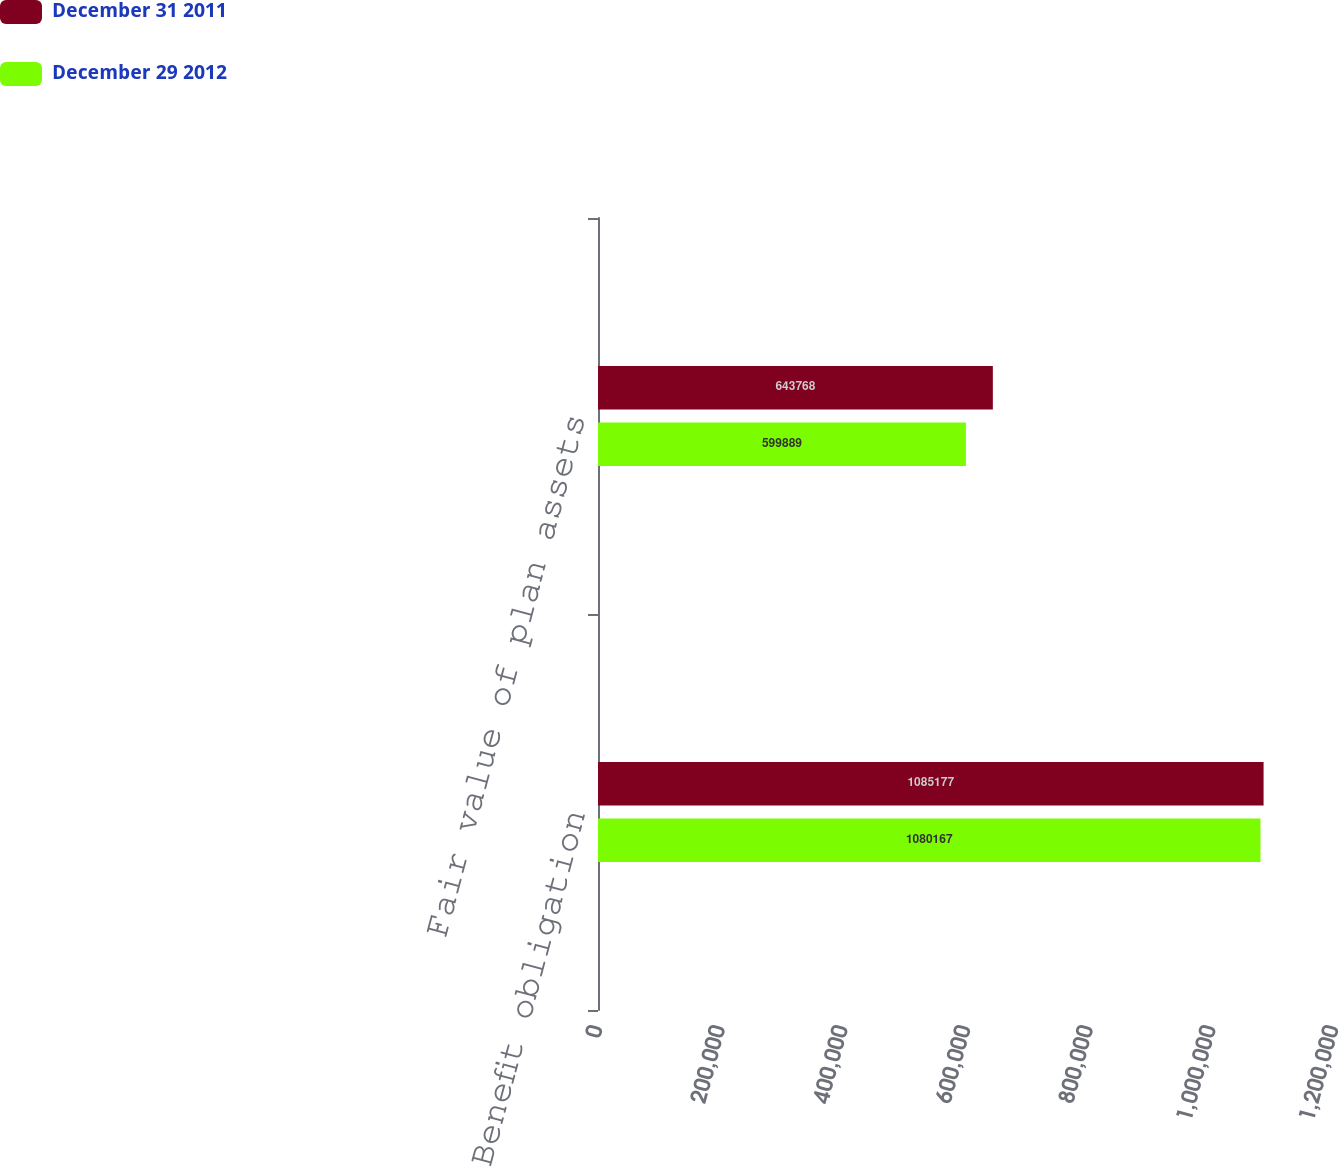Convert chart to OTSL. <chart><loc_0><loc_0><loc_500><loc_500><stacked_bar_chart><ecel><fcel>Benefit obligation<fcel>Fair value of plan assets<nl><fcel>December 31 2011<fcel>1.08518e+06<fcel>643768<nl><fcel>December 29 2012<fcel>1.08017e+06<fcel>599889<nl></chart> 